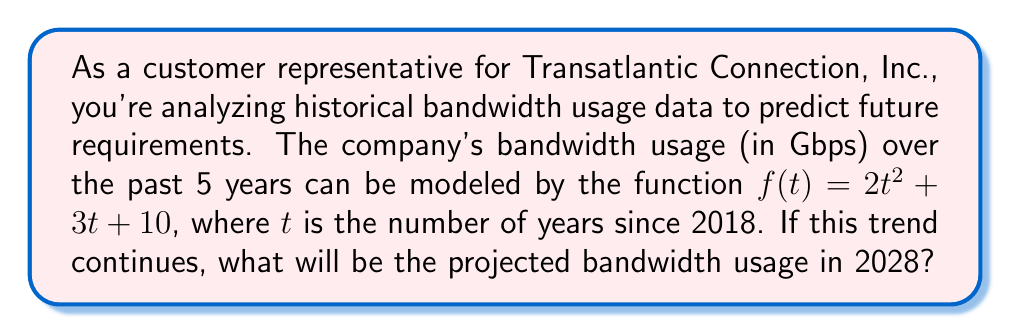Can you answer this question? To solve this problem, we'll follow these steps:

1. Identify the given information:
   - The bandwidth usage function is $f(t) = 2t^2 + 3t + 10$
   - $t$ is the number of years since 2018
   - We need to find the bandwidth usage in 2028

2. Calculate the value of $t$ for the year 2028:
   - 2028 is 10 years after 2018
   - So, $t = 10$

3. Substitute $t = 10$ into the function $f(t)$:
   $f(10) = 2(10)^2 + 3(10) + 10$

4. Evaluate the expression:
   $f(10) = 2(100) + 30 + 10$
   $f(10) = 200 + 30 + 10$
   $f(10) = 240$

Therefore, the projected bandwidth usage in 2028 will be 240 Gbps.
Answer: 240 Gbps 